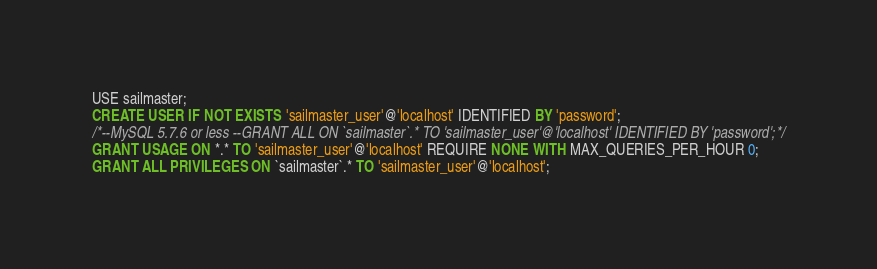<code> <loc_0><loc_0><loc_500><loc_500><_SQL_>USE sailmaster;
CREATE USER IF NOT EXISTS 'sailmaster_user'@'localhost' IDENTIFIED BY 'password';
/*--MySQL 5.7.6 or less --GRANT ALL ON `sailmaster`.* TO 'sailmaster_user'@'localhost' IDENTIFIED BY 'password';*/
GRANT USAGE ON *.* TO 'sailmaster_user'@'localhost' REQUIRE NONE WITH MAX_QUERIES_PER_HOUR 0;
GRANT ALL PRIVILEGES ON `sailmaster`.* TO 'sailmaster_user'@'localhost';
</code> 